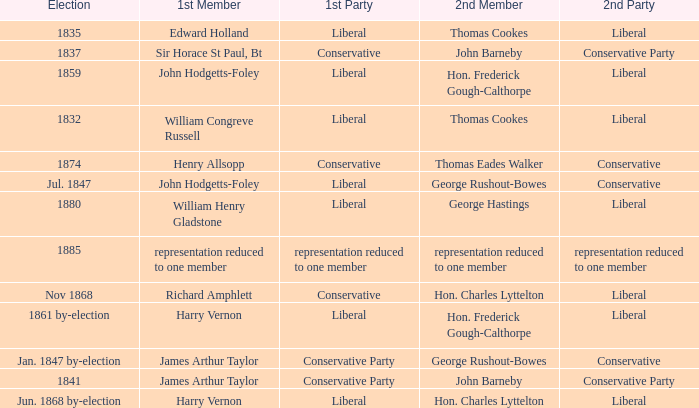What was the 1st Member when the 1st Party had its representation reduced to one member? Representation reduced to one member. 